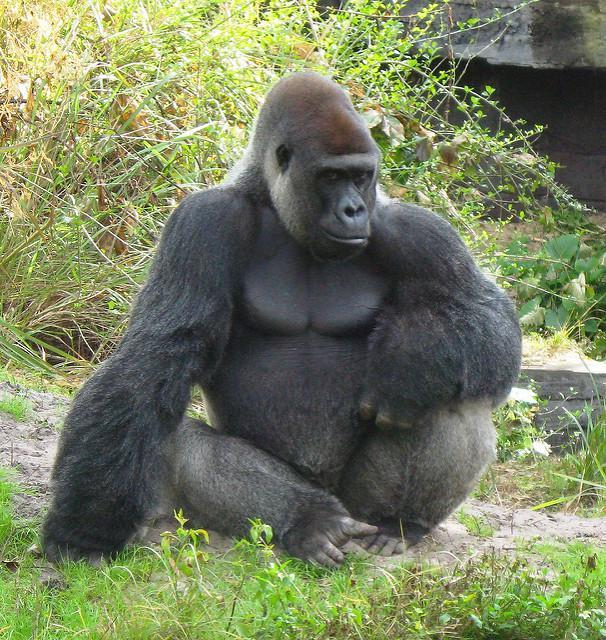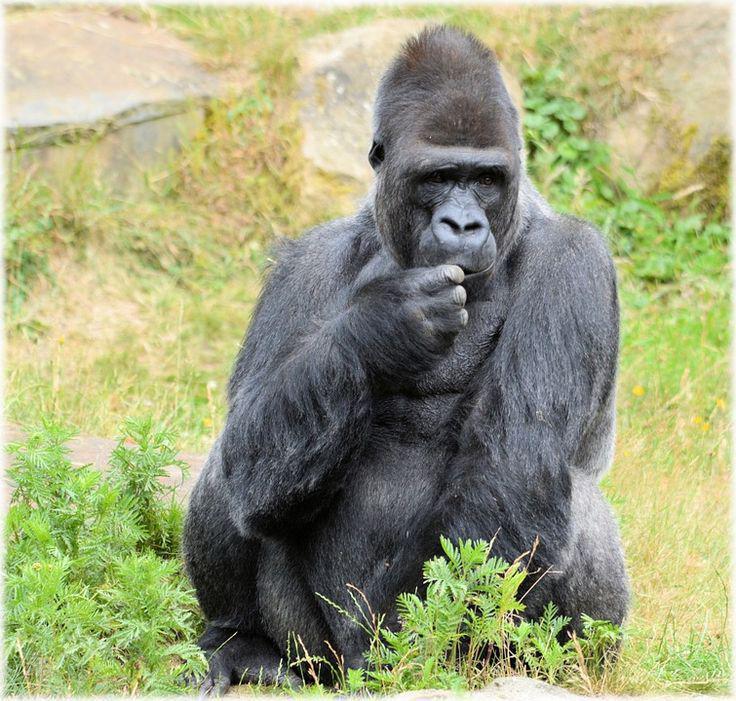The first image is the image on the left, the second image is the image on the right. Evaluate the accuracy of this statement regarding the images: "The gorilla in the image on the left is touching the ground with both of it's arms.". Is it true? Answer yes or no. No. 